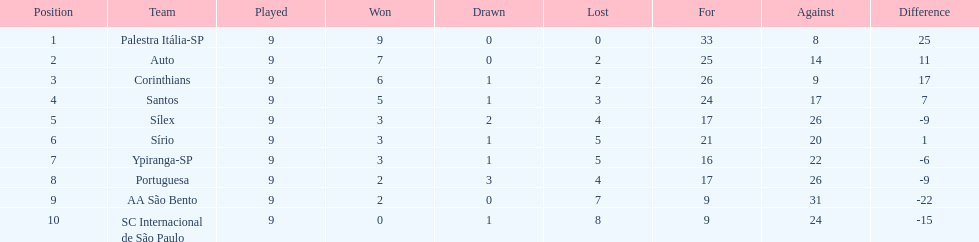In 1926, how many points were automatically awarded to the brazilian football team? 14. 